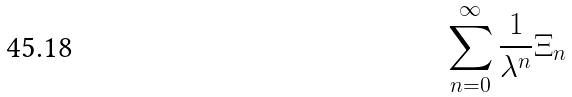Convert formula to latex. <formula><loc_0><loc_0><loc_500><loc_500>\sum _ { n = 0 } ^ { \infty } \frac { 1 } { \lambda ^ { n } } \Xi _ { n }</formula> 